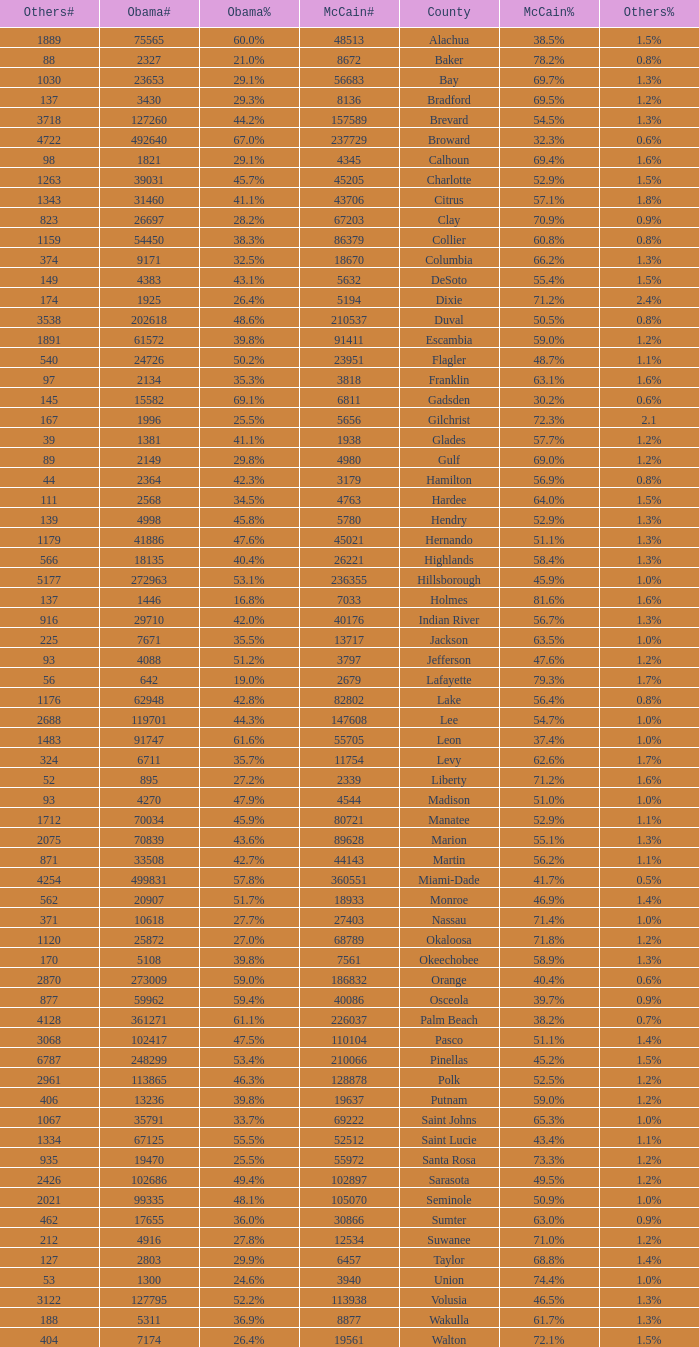What was the number of others votes in Columbia county? 374.0. 